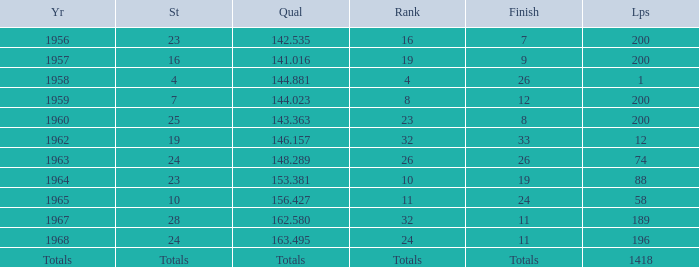Which qual also has a finish total of 9? 141.016. Could you parse the entire table as a dict? {'header': ['Yr', 'St', 'Qual', 'Rank', 'Finish', 'Lps'], 'rows': [['1956', '23', '142.535', '16', '7', '200'], ['1957', '16', '141.016', '19', '9', '200'], ['1958', '4', '144.881', '4', '26', '1'], ['1959', '7', '144.023', '8', '12', '200'], ['1960', '25', '143.363', '23', '8', '200'], ['1962', '19', '146.157', '32', '33', '12'], ['1963', '24', '148.289', '26', '26', '74'], ['1964', '23', '153.381', '10', '19', '88'], ['1965', '10', '156.427', '11', '24', '58'], ['1967', '28', '162.580', '32', '11', '189'], ['1968', '24', '163.495', '24', '11', '196'], ['Totals', 'Totals', 'Totals', 'Totals', 'Totals', '1418']]} 